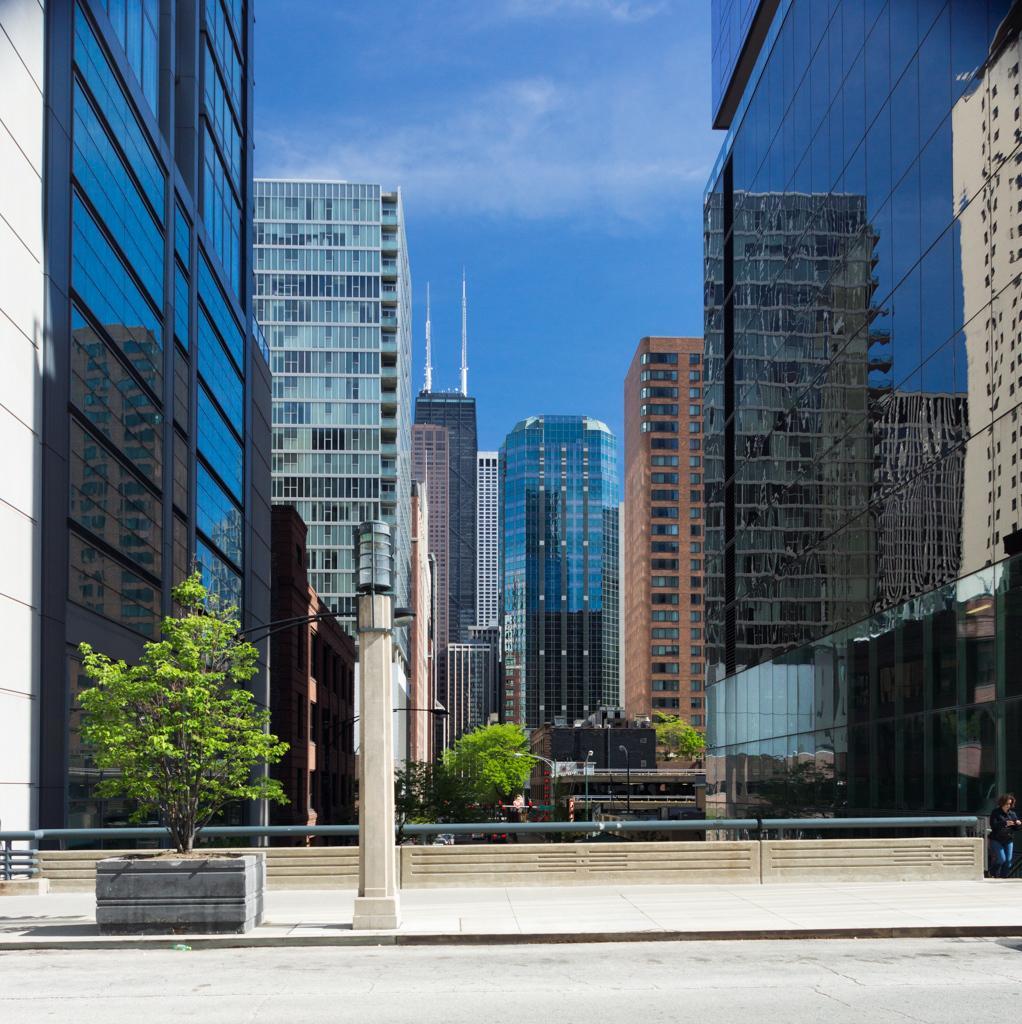Can you describe this image briefly? This picture is taken from the outside of the building. In this image, in the middle, we can see a pole. On the left side, we can see a plant. On the right side and left side, we can see glass buildings. In the background, we can see some towers, trees, plants. At the top, we can see a sky which is a bit cloudy, at the bottom, we can see a footpath and a road. 